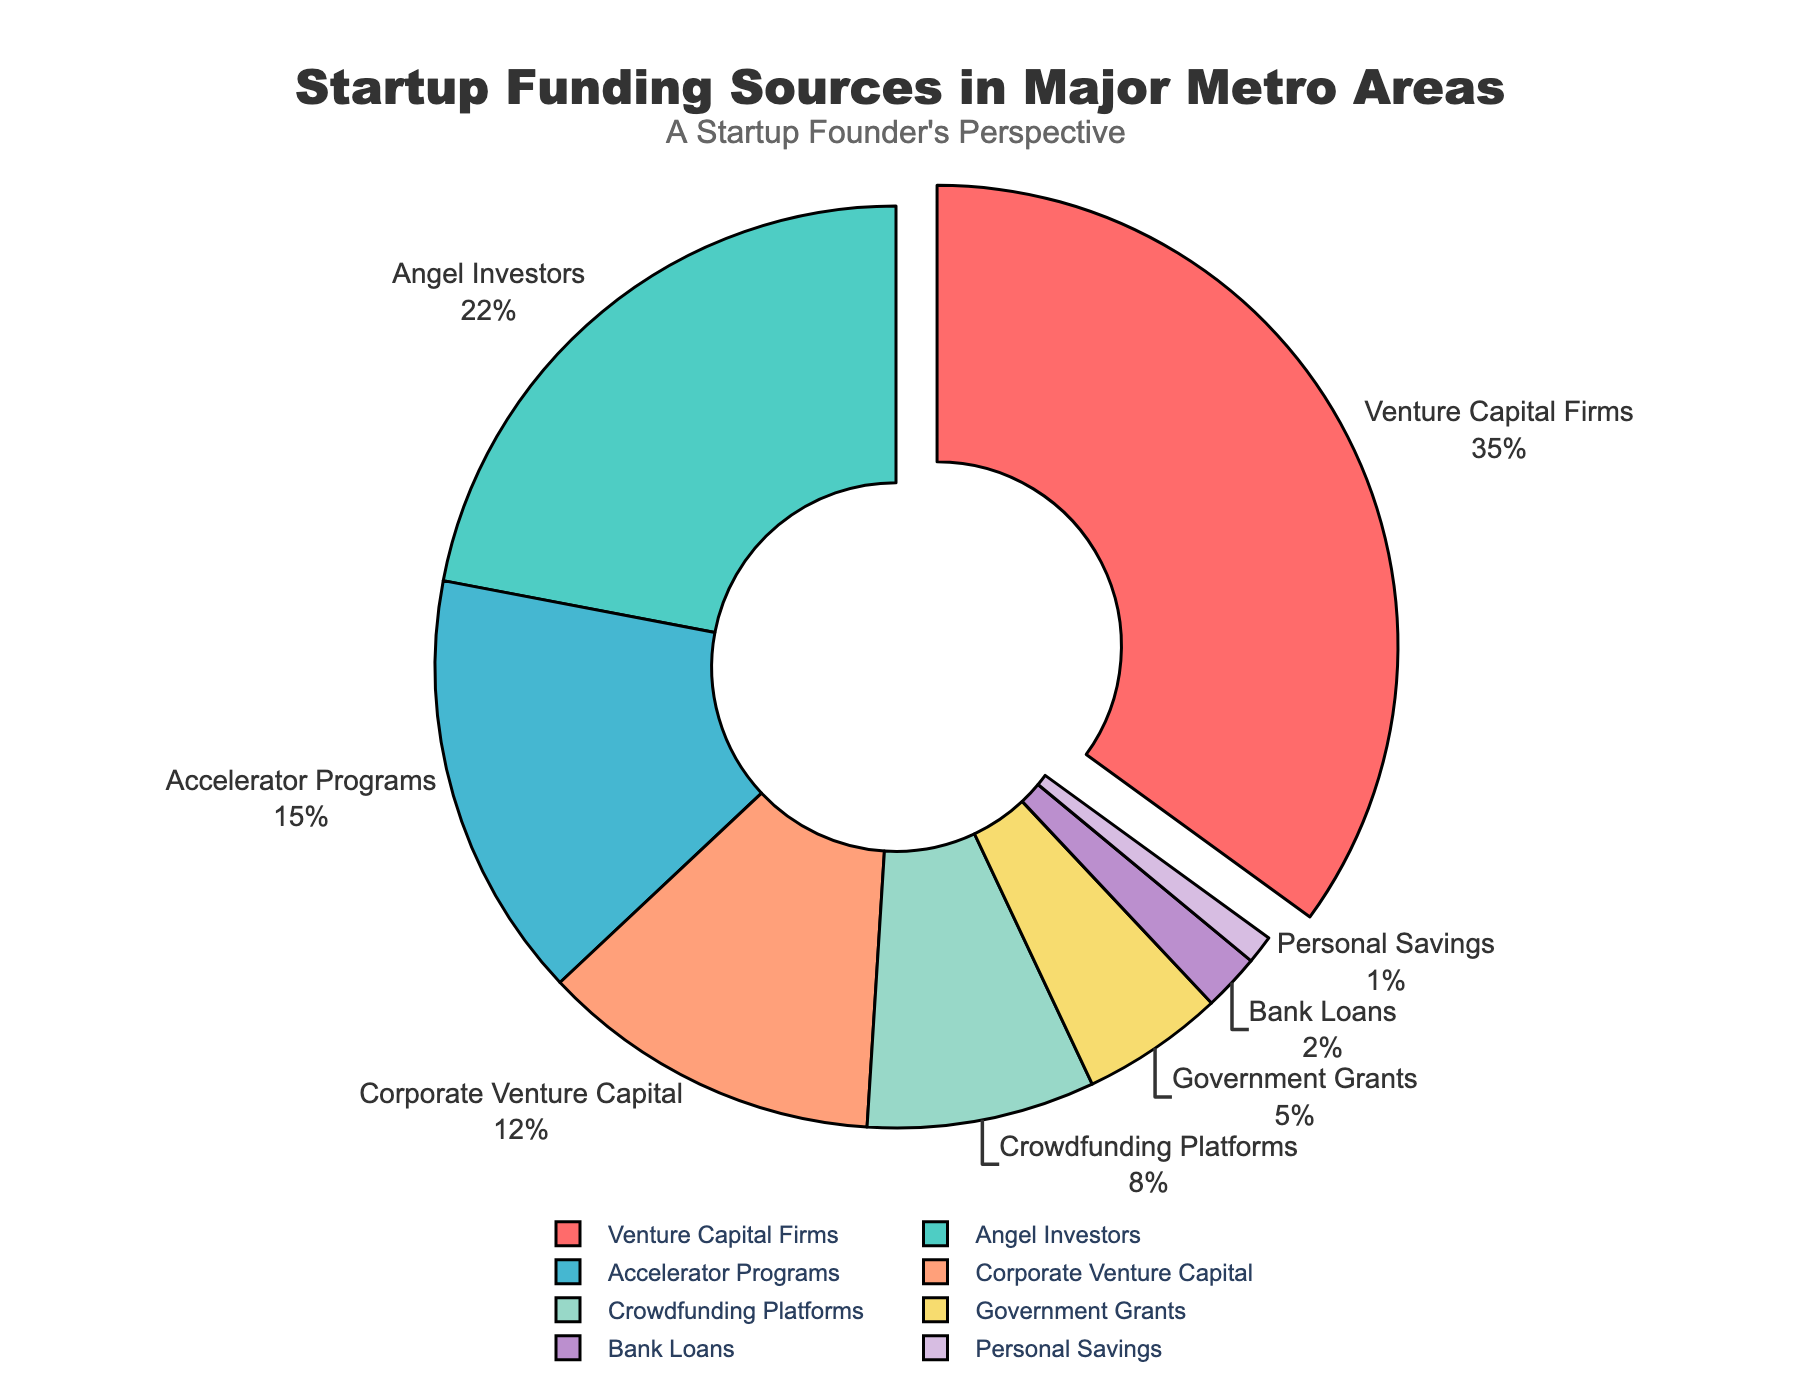What is the largest source of startup funding in major metropolitan areas? The largest section of the pie chart is labeled "Venture Capital Firms," making it evident that this is the largest source of startup funding.
Answer: Venture Capital Firms Which funding source contributes the least to startup funding? The smallest section of the pie chart is labeled "Personal Savings," indicating it contributes the least.
Answer: Personal Savings What percentage of startup funding comes from government sources (Government Grants) and personal sources (Personal Savings)? Add the percentage from "Government Grants" (5%) and "Personal Savings" (1%).
Answer: 6% How does the proportion of funding from Angel Investors compare to that from Accelerator Programs? The pie chart shows "Angel Investors" at 22% and "Accelerator Programs" at 15%, indicating that Angel Investors contribute a larger percentage.
Answer: Angel Investors contribute more Which type of funding is most likely to have a noticeable "pull" effect in the pie chart? The segment called "Venture Capital Firms" is pulled out of the pie chart, indicating it has the highest percentage and a noticeable pull effect.
Answer: Venture Capital Firms What visual feature highlights the top funding source in the pie chart? The top funding source, "Venture Capital Firms," is pulled out from the rest of the chart, highlighted by this visual separation.
Answer: Pulled out section Compare the combined percentage of Angel Investors and Corporate Venture Capital to Venture Capital Firms. Angel Investors and Corporate Venture Capital together make 22% + 12% = 34%, while Venture Capital Firms alone make up 35%.
Answer: Venture Capital Firms is higher How much more funding is provided by Crowdfunding Platforms compared to Bank Loans? The pie chart shows "Crowdfunding Platforms" at 8% and "Bank Loans" at 2%. The difference is 8% - 2%.
Answer: 6% Which funding sources together make up exactly half of the total funding? The pie chart shows that combining "Venture Capital Firms" (35%) and "Angel Investors" (22%) gives a total of 35% + 15% = 57%, and neither exactly hits 50%. However, combining "Venture Capital Firms" (35%), "Angel Investors" (22%), and "Accelerator Programs" (15%) gives more than half.
Answer: No single combination exactly makes 50% If Corporate Venture Capital doubled, what would its new percentage be and how would that compare to Venture Capital Firms? Currently, Corporate Venture Capital is at 12%. Doubling it would result in 12% * 2 = 24%, still less than Venture Capital Firms at 35%.
Answer: 24%, less than Venture Capital Firms 